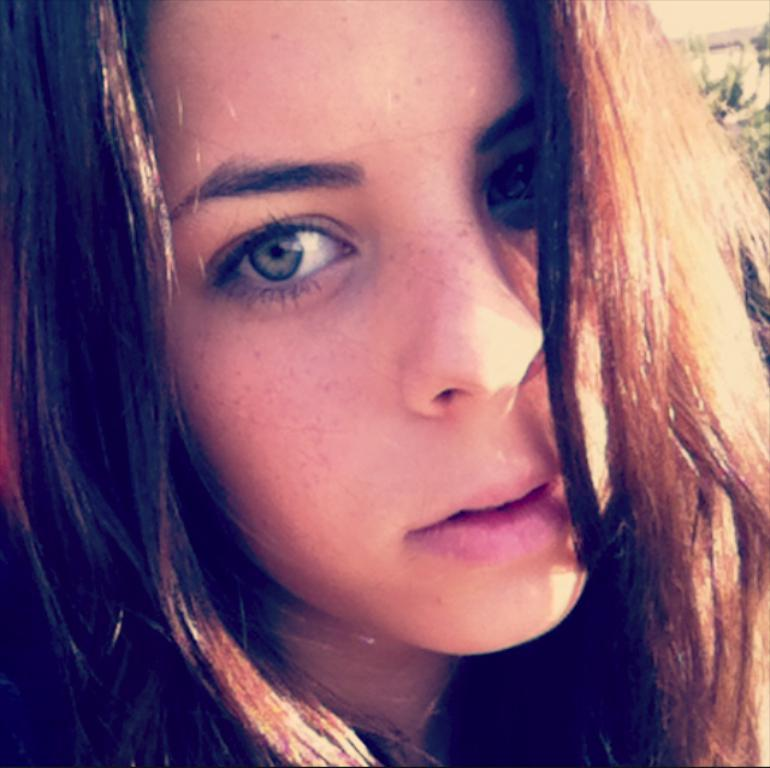What is the main subject of the image? There is a girl's face in the image. What can be seen in the background of the image? There are trees visible behind the girl. What is the weather like in the image? It is a sunny day. What type of attraction is the girl visiting in the image? There is no indication of an attraction in the image; it only shows the girl's face and trees in the background. What color is the orange the girl is holding in the image? There is no orange present in the image. 